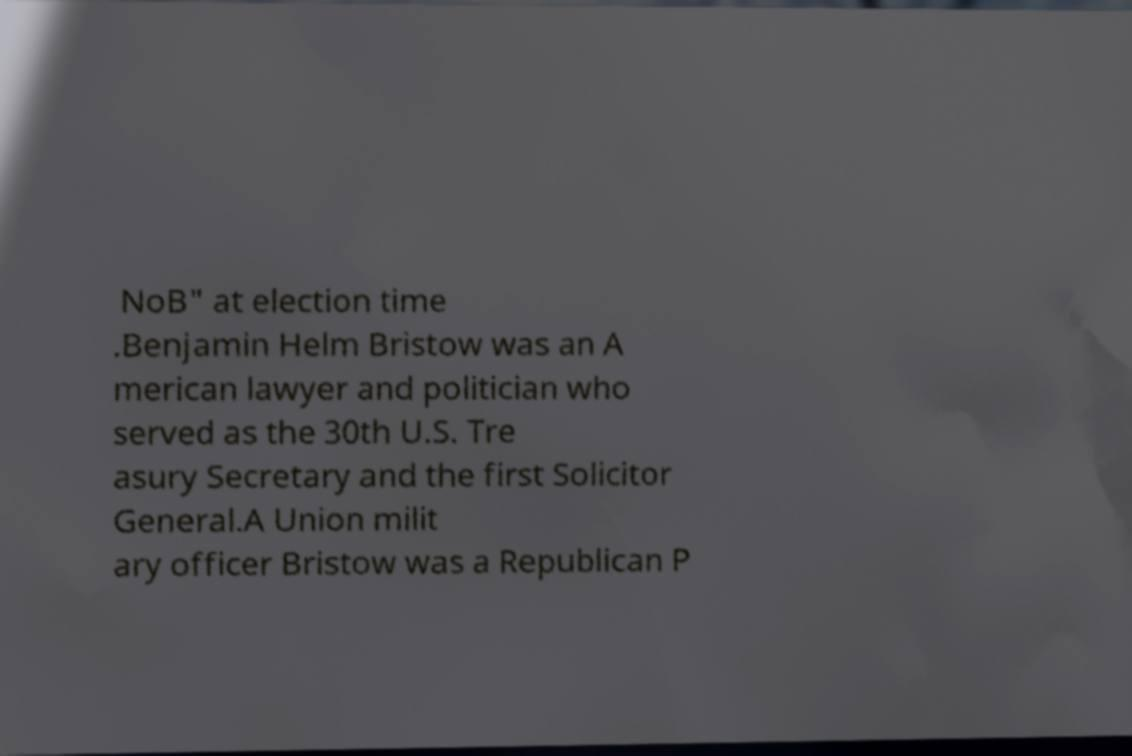What messages or text are displayed in this image? I need them in a readable, typed format. NoB" at election time .Benjamin Helm Bristow was an A merican lawyer and politician who served as the 30th U.S. Tre asury Secretary and the first Solicitor General.A Union milit ary officer Bristow was a Republican P 